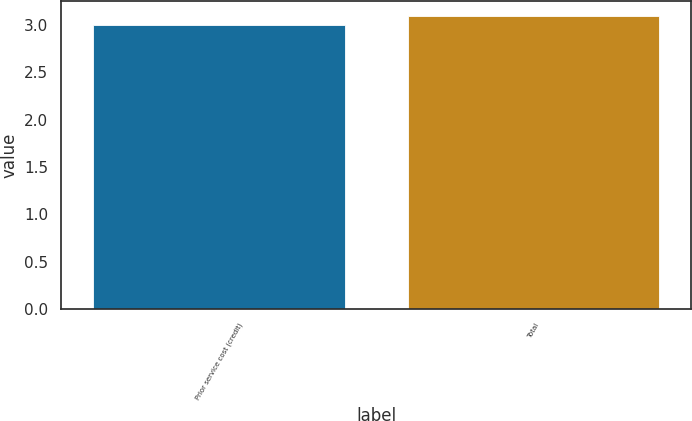<chart> <loc_0><loc_0><loc_500><loc_500><bar_chart><fcel>Prior service cost (credit)<fcel>Total<nl><fcel>3<fcel>3.1<nl></chart> 